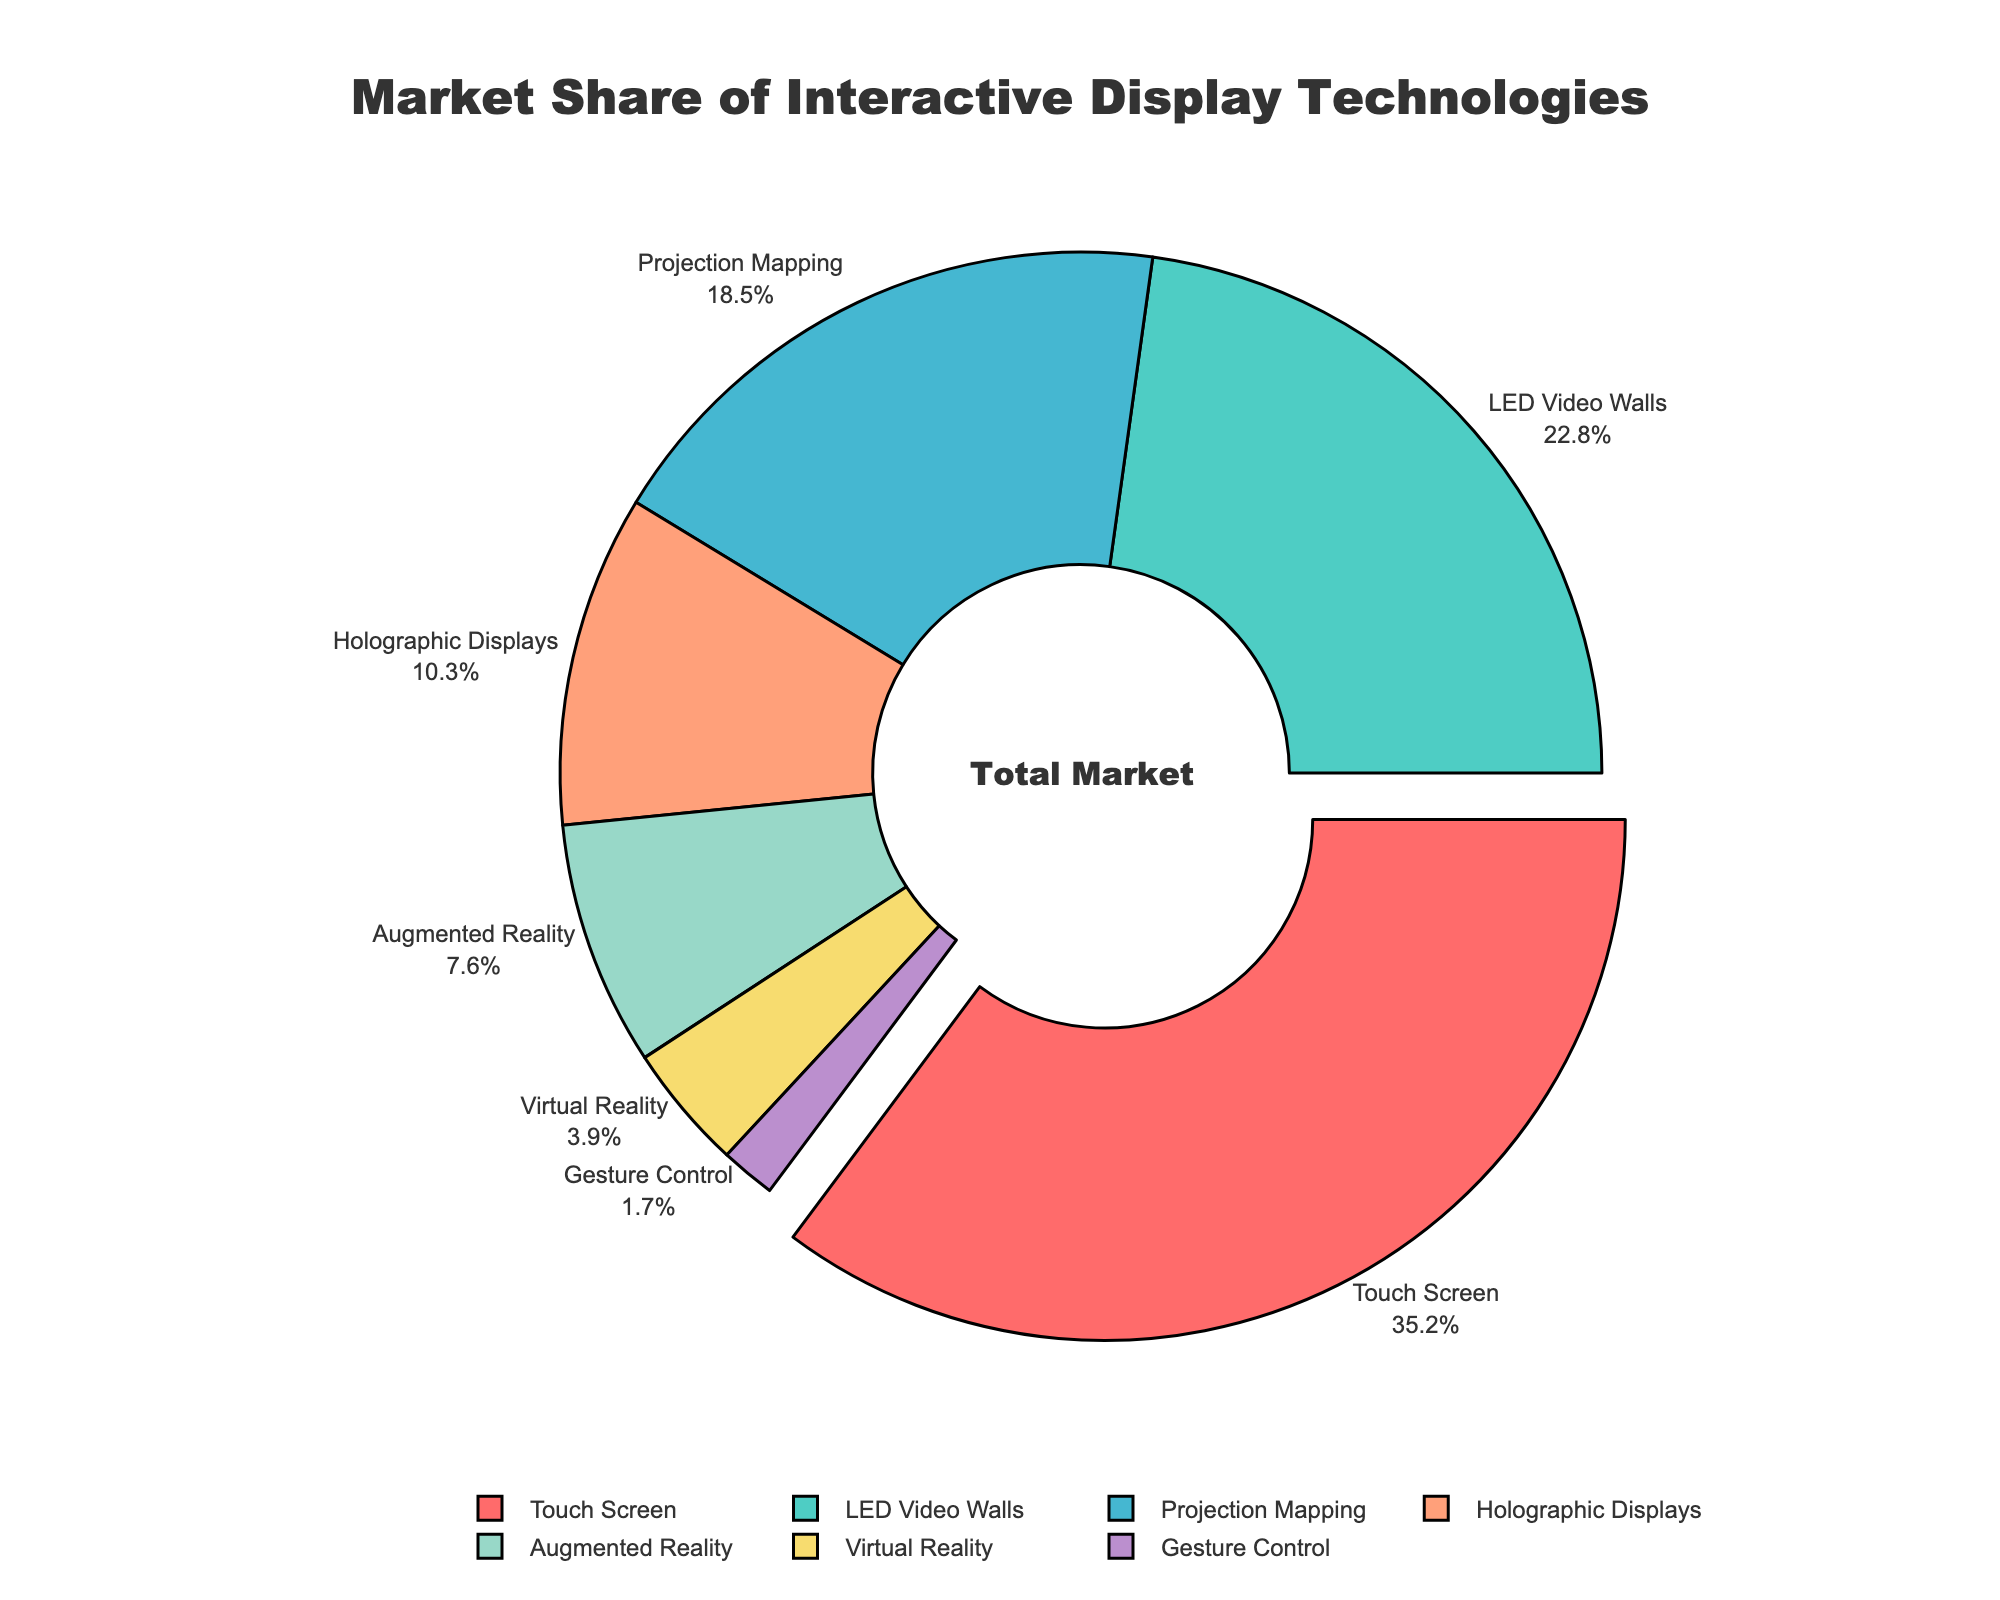What is the market share percentage of LED Video Walls? Identify the label corresponding to LED Video Walls and its associated percentage displayed on the pie chart.
Answer: 22.8% Which technology has the smallest market share? Locate the technology with the smallest slice of the pie chart, which corresponds to the lowest percentage.
Answer: Gesture Control What is the combined market share of Augmented Reality and Virtual Reality? Find the market share percentages for both Augmented Reality (7.6%) and Virtual Reality (3.9%), then add these values together: 7.6 + 3.9.
Answer: 11.5% How much larger is the market share of Touch Screen technology compared to Projection Mapping? Determine the market share of Touch Screen (35.2%) and Projection Mapping (18.5%), subtract the latter from the former: 35.2 - 18.5.
Answer: 16.7% What percentage of the market is taken up by Holographic Displays? Look for the label Holographic Displays on the pie chart and note its percentage value.
Answer: 10.3% Which technology has the largest market share and by what percentage? Identify the largest slice of the pie chart, associated with Touch Screen, and note its percentage.
Answer: Touch Screen, 35.2% What is the ratio of the market share of Touch Screen to Augmented Reality? Find the percentages of Touch Screen and Augmented Reality. Divide the market share of Touch Screen (35.2) by Augmented Reality (7.6): 35.2 / 7.6.
Answer: 4.63 How much more market share does LED Video Walls have compared to Holographic Displays? Find the market shares of LED Video Walls (22.8%) and Holographic Displays (10.3%), subtract the latter from the former: 22.8 - 10.3.
Answer: 12.5% What is the color of the segment representing Virtual Reality? Identify the color of the pie chart segment labeled Virtual Reality by visually inspecting the chart.
Answer: light yellow Which two technologies together make up more than half of the market share? Determine the combined market share of pairs of technologies. The pair Touch Screen (35.2%) and LED Video Walls (22.8%) together make up 35.2 + 22.8 = 58%.
Answer: Touch Screen and LED Video Walls 